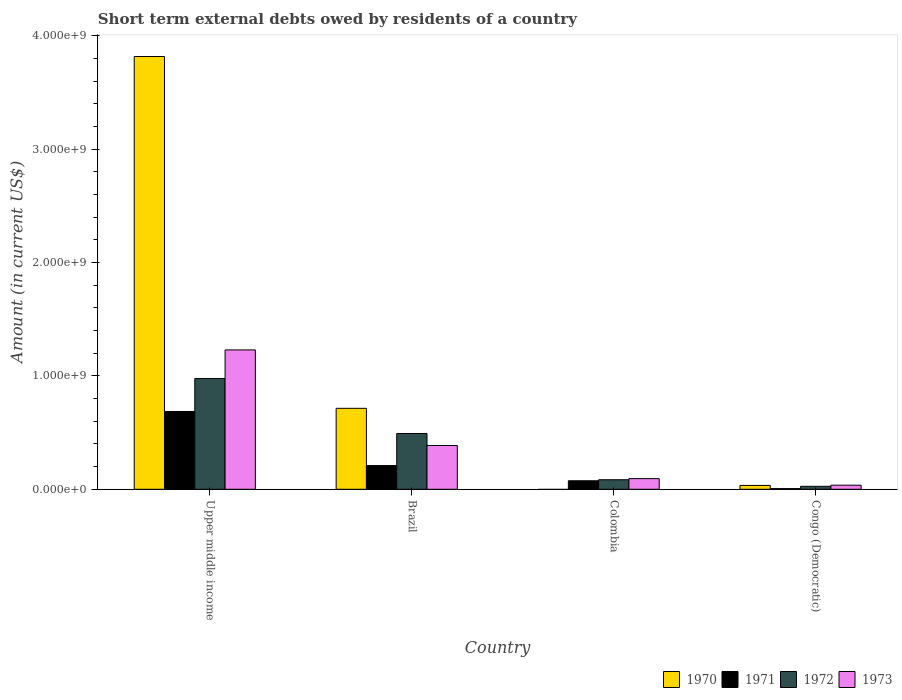How many bars are there on the 4th tick from the left?
Your answer should be very brief. 4. In how many cases, is the number of bars for a given country not equal to the number of legend labels?
Make the answer very short. 1. What is the amount of short-term external debts owed by residents in 1972 in Upper middle income?
Your answer should be very brief. 9.77e+08. Across all countries, what is the maximum amount of short-term external debts owed by residents in 1971?
Provide a short and direct response. 6.86e+08. Across all countries, what is the minimum amount of short-term external debts owed by residents in 1972?
Make the answer very short. 2.60e+07. In which country was the amount of short-term external debts owed by residents in 1970 maximum?
Ensure brevity in your answer.  Upper middle income. What is the total amount of short-term external debts owed by residents in 1973 in the graph?
Make the answer very short. 1.75e+09. What is the difference between the amount of short-term external debts owed by residents in 1971 in Brazil and that in Congo (Democratic)?
Provide a short and direct response. 2.03e+08. What is the difference between the amount of short-term external debts owed by residents in 1972 in Congo (Democratic) and the amount of short-term external debts owed by residents in 1971 in Upper middle income?
Keep it short and to the point. -6.60e+08. What is the average amount of short-term external debts owed by residents in 1971 per country?
Give a very brief answer. 2.44e+08. What is the difference between the amount of short-term external debts owed by residents of/in 1972 and amount of short-term external debts owed by residents of/in 1973 in Colombia?
Provide a short and direct response. -1.00e+07. In how many countries, is the amount of short-term external debts owed by residents in 1973 greater than 1600000000 US$?
Give a very brief answer. 0. What is the ratio of the amount of short-term external debts owed by residents in 1970 in Brazil to that in Congo (Democratic)?
Give a very brief answer. 21. What is the difference between the highest and the second highest amount of short-term external debts owed by residents in 1972?
Offer a terse response. 4.85e+08. What is the difference between the highest and the lowest amount of short-term external debts owed by residents in 1973?
Provide a short and direct response. 1.19e+09. Is it the case that in every country, the sum of the amount of short-term external debts owed by residents in 1970 and amount of short-term external debts owed by residents in 1973 is greater than the amount of short-term external debts owed by residents in 1972?
Provide a succinct answer. Yes. Are all the bars in the graph horizontal?
Offer a very short reply. No. How many countries are there in the graph?
Your answer should be compact. 4. What is the difference between two consecutive major ticks on the Y-axis?
Your response must be concise. 1.00e+09. Are the values on the major ticks of Y-axis written in scientific E-notation?
Give a very brief answer. Yes. Does the graph contain any zero values?
Offer a terse response. Yes. Does the graph contain grids?
Give a very brief answer. No. Where does the legend appear in the graph?
Your answer should be compact. Bottom right. How many legend labels are there?
Offer a terse response. 4. How are the legend labels stacked?
Your answer should be very brief. Horizontal. What is the title of the graph?
Offer a very short reply. Short term external debts owed by residents of a country. Does "1990" appear as one of the legend labels in the graph?
Give a very brief answer. No. What is the label or title of the X-axis?
Offer a terse response. Country. What is the label or title of the Y-axis?
Keep it short and to the point. Amount (in current US$). What is the Amount (in current US$) in 1970 in Upper middle income?
Your answer should be compact. 3.82e+09. What is the Amount (in current US$) in 1971 in Upper middle income?
Give a very brief answer. 6.86e+08. What is the Amount (in current US$) in 1972 in Upper middle income?
Give a very brief answer. 9.77e+08. What is the Amount (in current US$) of 1973 in Upper middle income?
Ensure brevity in your answer.  1.23e+09. What is the Amount (in current US$) of 1970 in Brazil?
Offer a terse response. 7.14e+08. What is the Amount (in current US$) of 1971 in Brazil?
Your answer should be very brief. 2.09e+08. What is the Amount (in current US$) of 1972 in Brazil?
Give a very brief answer. 4.92e+08. What is the Amount (in current US$) in 1973 in Brazil?
Keep it short and to the point. 3.86e+08. What is the Amount (in current US$) of 1970 in Colombia?
Give a very brief answer. 0. What is the Amount (in current US$) of 1971 in Colombia?
Make the answer very short. 7.50e+07. What is the Amount (in current US$) in 1972 in Colombia?
Ensure brevity in your answer.  8.40e+07. What is the Amount (in current US$) of 1973 in Colombia?
Ensure brevity in your answer.  9.40e+07. What is the Amount (in current US$) in 1970 in Congo (Democratic)?
Offer a very short reply. 3.40e+07. What is the Amount (in current US$) in 1971 in Congo (Democratic)?
Offer a terse response. 6.00e+06. What is the Amount (in current US$) in 1972 in Congo (Democratic)?
Ensure brevity in your answer.  2.60e+07. What is the Amount (in current US$) in 1973 in Congo (Democratic)?
Make the answer very short. 3.60e+07. Across all countries, what is the maximum Amount (in current US$) of 1970?
Your answer should be very brief. 3.82e+09. Across all countries, what is the maximum Amount (in current US$) of 1971?
Give a very brief answer. 6.86e+08. Across all countries, what is the maximum Amount (in current US$) of 1972?
Provide a succinct answer. 9.77e+08. Across all countries, what is the maximum Amount (in current US$) in 1973?
Ensure brevity in your answer.  1.23e+09. Across all countries, what is the minimum Amount (in current US$) of 1971?
Give a very brief answer. 6.00e+06. Across all countries, what is the minimum Amount (in current US$) in 1972?
Your answer should be very brief. 2.60e+07. Across all countries, what is the minimum Amount (in current US$) of 1973?
Ensure brevity in your answer.  3.60e+07. What is the total Amount (in current US$) in 1970 in the graph?
Offer a very short reply. 4.56e+09. What is the total Amount (in current US$) in 1971 in the graph?
Offer a terse response. 9.76e+08. What is the total Amount (in current US$) in 1972 in the graph?
Your response must be concise. 1.58e+09. What is the total Amount (in current US$) in 1973 in the graph?
Make the answer very short. 1.75e+09. What is the difference between the Amount (in current US$) in 1970 in Upper middle income and that in Brazil?
Provide a succinct answer. 3.10e+09. What is the difference between the Amount (in current US$) of 1971 in Upper middle income and that in Brazil?
Keep it short and to the point. 4.77e+08. What is the difference between the Amount (in current US$) of 1972 in Upper middle income and that in Brazil?
Your response must be concise. 4.85e+08. What is the difference between the Amount (in current US$) in 1973 in Upper middle income and that in Brazil?
Offer a terse response. 8.43e+08. What is the difference between the Amount (in current US$) of 1971 in Upper middle income and that in Colombia?
Make the answer very short. 6.11e+08. What is the difference between the Amount (in current US$) in 1972 in Upper middle income and that in Colombia?
Your response must be concise. 8.93e+08. What is the difference between the Amount (in current US$) in 1973 in Upper middle income and that in Colombia?
Provide a succinct answer. 1.14e+09. What is the difference between the Amount (in current US$) of 1970 in Upper middle income and that in Congo (Democratic)?
Provide a short and direct response. 3.78e+09. What is the difference between the Amount (in current US$) in 1971 in Upper middle income and that in Congo (Democratic)?
Give a very brief answer. 6.80e+08. What is the difference between the Amount (in current US$) of 1972 in Upper middle income and that in Congo (Democratic)?
Provide a succinct answer. 9.51e+08. What is the difference between the Amount (in current US$) of 1973 in Upper middle income and that in Congo (Democratic)?
Make the answer very short. 1.19e+09. What is the difference between the Amount (in current US$) in 1971 in Brazil and that in Colombia?
Make the answer very short. 1.34e+08. What is the difference between the Amount (in current US$) in 1972 in Brazil and that in Colombia?
Offer a terse response. 4.08e+08. What is the difference between the Amount (in current US$) in 1973 in Brazil and that in Colombia?
Your answer should be compact. 2.92e+08. What is the difference between the Amount (in current US$) of 1970 in Brazil and that in Congo (Democratic)?
Ensure brevity in your answer.  6.80e+08. What is the difference between the Amount (in current US$) of 1971 in Brazil and that in Congo (Democratic)?
Your response must be concise. 2.03e+08. What is the difference between the Amount (in current US$) of 1972 in Brazil and that in Congo (Democratic)?
Your answer should be very brief. 4.66e+08. What is the difference between the Amount (in current US$) of 1973 in Brazil and that in Congo (Democratic)?
Provide a succinct answer. 3.50e+08. What is the difference between the Amount (in current US$) in 1971 in Colombia and that in Congo (Democratic)?
Give a very brief answer. 6.90e+07. What is the difference between the Amount (in current US$) in 1972 in Colombia and that in Congo (Democratic)?
Your response must be concise. 5.80e+07. What is the difference between the Amount (in current US$) in 1973 in Colombia and that in Congo (Democratic)?
Give a very brief answer. 5.80e+07. What is the difference between the Amount (in current US$) in 1970 in Upper middle income and the Amount (in current US$) in 1971 in Brazil?
Your answer should be compact. 3.61e+09. What is the difference between the Amount (in current US$) in 1970 in Upper middle income and the Amount (in current US$) in 1972 in Brazil?
Make the answer very short. 3.32e+09. What is the difference between the Amount (in current US$) of 1970 in Upper middle income and the Amount (in current US$) of 1973 in Brazil?
Keep it short and to the point. 3.43e+09. What is the difference between the Amount (in current US$) of 1971 in Upper middle income and the Amount (in current US$) of 1972 in Brazil?
Your answer should be compact. 1.94e+08. What is the difference between the Amount (in current US$) in 1971 in Upper middle income and the Amount (in current US$) in 1973 in Brazil?
Ensure brevity in your answer.  3.00e+08. What is the difference between the Amount (in current US$) of 1972 in Upper middle income and the Amount (in current US$) of 1973 in Brazil?
Ensure brevity in your answer.  5.91e+08. What is the difference between the Amount (in current US$) in 1970 in Upper middle income and the Amount (in current US$) in 1971 in Colombia?
Ensure brevity in your answer.  3.74e+09. What is the difference between the Amount (in current US$) of 1970 in Upper middle income and the Amount (in current US$) of 1972 in Colombia?
Make the answer very short. 3.73e+09. What is the difference between the Amount (in current US$) in 1970 in Upper middle income and the Amount (in current US$) in 1973 in Colombia?
Your answer should be compact. 3.72e+09. What is the difference between the Amount (in current US$) in 1971 in Upper middle income and the Amount (in current US$) in 1972 in Colombia?
Your answer should be very brief. 6.02e+08. What is the difference between the Amount (in current US$) of 1971 in Upper middle income and the Amount (in current US$) of 1973 in Colombia?
Offer a very short reply. 5.92e+08. What is the difference between the Amount (in current US$) in 1972 in Upper middle income and the Amount (in current US$) in 1973 in Colombia?
Your answer should be very brief. 8.83e+08. What is the difference between the Amount (in current US$) in 1970 in Upper middle income and the Amount (in current US$) in 1971 in Congo (Democratic)?
Offer a very short reply. 3.81e+09. What is the difference between the Amount (in current US$) in 1970 in Upper middle income and the Amount (in current US$) in 1972 in Congo (Democratic)?
Provide a short and direct response. 3.79e+09. What is the difference between the Amount (in current US$) in 1970 in Upper middle income and the Amount (in current US$) in 1973 in Congo (Democratic)?
Provide a short and direct response. 3.78e+09. What is the difference between the Amount (in current US$) in 1971 in Upper middle income and the Amount (in current US$) in 1972 in Congo (Democratic)?
Give a very brief answer. 6.60e+08. What is the difference between the Amount (in current US$) in 1971 in Upper middle income and the Amount (in current US$) in 1973 in Congo (Democratic)?
Ensure brevity in your answer.  6.50e+08. What is the difference between the Amount (in current US$) in 1972 in Upper middle income and the Amount (in current US$) in 1973 in Congo (Democratic)?
Make the answer very short. 9.41e+08. What is the difference between the Amount (in current US$) of 1970 in Brazil and the Amount (in current US$) of 1971 in Colombia?
Provide a succinct answer. 6.39e+08. What is the difference between the Amount (in current US$) of 1970 in Brazil and the Amount (in current US$) of 1972 in Colombia?
Give a very brief answer. 6.30e+08. What is the difference between the Amount (in current US$) in 1970 in Brazil and the Amount (in current US$) in 1973 in Colombia?
Ensure brevity in your answer.  6.20e+08. What is the difference between the Amount (in current US$) of 1971 in Brazil and the Amount (in current US$) of 1972 in Colombia?
Ensure brevity in your answer.  1.25e+08. What is the difference between the Amount (in current US$) in 1971 in Brazil and the Amount (in current US$) in 1973 in Colombia?
Offer a very short reply. 1.15e+08. What is the difference between the Amount (in current US$) in 1972 in Brazil and the Amount (in current US$) in 1973 in Colombia?
Provide a succinct answer. 3.98e+08. What is the difference between the Amount (in current US$) in 1970 in Brazil and the Amount (in current US$) in 1971 in Congo (Democratic)?
Your response must be concise. 7.08e+08. What is the difference between the Amount (in current US$) in 1970 in Brazil and the Amount (in current US$) in 1972 in Congo (Democratic)?
Offer a terse response. 6.88e+08. What is the difference between the Amount (in current US$) in 1970 in Brazil and the Amount (in current US$) in 1973 in Congo (Democratic)?
Ensure brevity in your answer.  6.78e+08. What is the difference between the Amount (in current US$) of 1971 in Brazil and the Amount (in current US$) of 1972 in Congo (Democratic)?
Provide a short and direct response. 1.83e+08. What is the difference between the Amount (in current US$) in 1971 in Brazil and the Amount (in current US$) in 1973 in Congo (Democratic)?
Provide a succinct answer. 1.73e+08. What is the difference between the Amount (in current US$) of 1972 in Brazil and the Amount (in current US$) of 1973 in Congo (Democratic)?
Offer a terse response. 4.56e+08. What is the difference between the Amount (in current US$) of 1971 in Colombia and the Amount (in current US$) of 1972 in Congo (Democratic)?
Keep it short and to the point. 4.90e+07. What is the difference between the Amount (in current US$) in 1971 in Colombia and the Amount (in current US$) in 1973 in Congo (Democratic)?
Keep it short and to the point. 3.90e+07. What is the difference between the Amount (in current US$) of 1972 in Colombia and the Amount (in current US$) of 1973 in Congo (Democratic)?
Offer a very short reply. 4.80e+07. What is the average Amount (in current US$) in 1970 per country?
Your response must be concise. 1.14e+09. What is the average Amount (in current US$) of 1971 per country?
Make the answer very short. 2.44e+08. What is the average Amount (in current US$) of 1972 per country?
Keep it short and to the point. 3.95e+08. What is the average Amount (in current US$) in 1973 per country?
Provide a succinct answer. 4.36e+08. What is the difference between the Amount (in current US$) of 1970 and Amount (in current US$) of 1971 in Upper middle income?
Make the answer very short. 3.13e+09. What is the difference between the Amount (in current US$) in 1970 and Amount (in current US$) in 1972 in Upper middle income?
Your answer should be compact. 2.84e+09. What is the difference between the Amount (in current US$) in 1970 and Amount (in current US$) in 1973 in Upper middle income?
Your answer should be compact. 2.59e+09. What is the difference between the Amount (in current US$) of 1971 and Amount (in current US$) of 1972 in Upper middle income?
Provide a succinct answer. -2.91e+08. What is the difference between the Amount (in current US$) in 1971 and Amount (in current US$) in 1973 in Upper middle income?
Give a very brief answer. -5.43e+08. What is the difference between the Amount (in current US$) in 1972 and Amount (in current US$) in 1973 in Upper middle income?
Ensure brevity in your answer.  -2.52e+08. What is the difference between the Amount (in current US$) in 1970 and Amount (in current US$) in 1971 in Brazil?
Ensure brevity in your answer.  5.05e+08. What is the difference between the Amount (in current US$) of 1970 and Amount (in current US$) of 1972 in Brazil?
Provide a succinct answer. 2.22e+08. What is the difference between the Amount (in current US$) of 1970 and Amount (in current US$) of 1973 in Brazil?
Provide a succinct answer. 3.28e+08. What is the difference between the Amount (in current US$) of 1971 and Amount (in current US$) of 1972 in Brazil?
Your answer should be very brief. -2.83e+08. What is the difference between the Amount (in current US$) in 1971 and Amount (in current US$) in 1973 in Brazil?
Your answer should be compact. -1.77e+08. What is the difference between the Amount (in current US$) of 1972 and Amount (in current US$) of 1973 in Brazil?
Keep it short and to the point. 1.06e+08. What is the difference between the Amount (in current US$) in 1971 and Amount (in current US$) in 1972 in Colombia?
Make the answer very short. -9.00e+06. What is the difference between the Amount (in current US$) in 1971 and Amount (in current US$) in 1973 in Colombia?
Ensure brevity in your answer.  -1.90e+07. What is the difference between the Amount (in current US$) of 1972 and Amount (in current US$) of 1973 in Colombia?
Ensure brevity in your answer.  -1.00e+07. What is the difference between the Amount (in current US$) in 1970 and Amount (in current US$) in 1971 in Congo (Democratic)?
Your response must be concise. 2.80e+07. What is the difference between the Amount (in current US$) of 1970 and Amount (in current US$) of 1972 in Congo (Democratic)?
Make the answer very short. 8.00e+06. What is the difference between the Amount (in current US$) in 1970 and Amount (in current US$) in 1973 in Congo (Democratic)?
Offer a very short reply. -2.00e+06. What is the difference between the Amount (in current US$) in 1971 and Amount (in current US$) in 1972 in Congo (Democratic)?
Make the answer very short. -2.00e+07. What is the difference between the Amount (in current US$) of 1971 and Amount (in current US$) of 1973 in Congo (Democratic)?
Provide a succinct answer. -3.00e+07. What is the difference between the Amount (in current US$) in 1972 and Amount (in current US$) in 1973 in Congo (Democratic)?
Offer a terse response. -1.00e+07. What is the ratio of the Amount (in current US$) of 1970 in Upper middle income to that in Brazil?
Offer a very short reply. 5.35. What is the ratio of the Amount (in current US$) of 1971 in Upper middle income to that in Brazil?
Offer a terse response. 3.28. What is the ratio of the Amount (in current US$) of 1972 in Upper middle income to that in Brazil?
Make the answer very short. 1.99. What is the ratio of the Amount (in current US$) in 1973 in Upper middle income to that in Brazil?
Provide a succinct answer. 3.18. What is the ratio of the Amount (in current US$) of 1971 in Upper middle income to that in Colombia?
Make the answer very short. 9.15. What is the ratio of the Amount (in current US$) in 1972 in Upper middle income to that in Colombia?
Ensure brevity in your answer.  11.63. What is the ratio of the Amount (in current US$) of 1973 in Upper middle income to that in Colombia?
Provide a succinct answer. 13.08. What is the ratio of the Amount (in current US$) of 1970 in Upper middle income to that in Congo (Democratic)?
Give a very brief answer. 112.25. What is the ratio of the Amount (in current US$) in 1971 in Upper middle income to that in Congo (Democratic)?
Keep it short and to the point. 114.35. What is the ratio of the Amount (in current US$) of 1972 in Upper middle income to that in Congo (Democratic)?
Give a very brief answer. 37.58. What is the ratio of the Amount (in current US$) of 1973 in Upper middle income to that in Congo (Democratic)?
Keep it short and to the point. 34.14. What is the ratio of the Amount (in current US$) of 1971 in Brazil to that in Colombia?
Make the answer very short. 2.79. What is the ratio of the Amount (in current US$) of 1972 in Brazil to that in Colombia?
Provide a succinct answer. 5.86. What is the ratio of the Amount (in current US$) in 1973 in Brazil to that in Colombia?
Your answer should be very brief. 4.11. What is the ratio of the Amount (in current US$) in 1971 in Brazil to that in Congo (Democratic)?
Keep it short and to the point. 34.83. What is the ratio of the Amount (in current US$) of 1972 in Brazil to that in Congo (Democratic)?
Keep it short and to the point. 18.92. What is the ratio of the Amount (in current US$) in 1973 in Brazil to that in Congo (Democratic)?
Make the answer very short. 10.72. What is the ratio of the Amount (in current US$) in 1972 in Colombia to that in Congo (Democratic)?
Make the answer very short. 3.23. What is the ratio of the Amount (in current US$) in 1973 in Colombia to that in Congo (Democratic)?
Provide a short and direct response. 2.61. What is the difference between the highest and the second highest Amount (in current US$) of 1970?
Offer a terse response. 3.10e+09. What is the difference between the highest and the second highest Amount (in current US$) in 1971?
Your response must be concise. 4.77e+08. What is the difference between the highest and the second highest Amount (in current US$) in 1972?
Offer a very short reply. 4.85e+08. What is the difference between the highest and the second highest Amount (in current US$) of 1973?
Ensure brevity in your answer.  8.43e+08. What is the difference between the highest and the lowest Amount (in current US$) in 1970?
Provide a short and direct response. 3.82e+09. What is the difference between the highest and the lowest Amount (in current US$) of 1971?
Provide a short and direct response. 6.80e+08. What is the difference between the highest and the lowest Amount (in current US$) of 1972?
Your answer should be compact. 9.51e+08. What is the difference between the highest and the lowest Amount (in current US$) in 1973?
Give a very brief answer. 1.19e+09. 